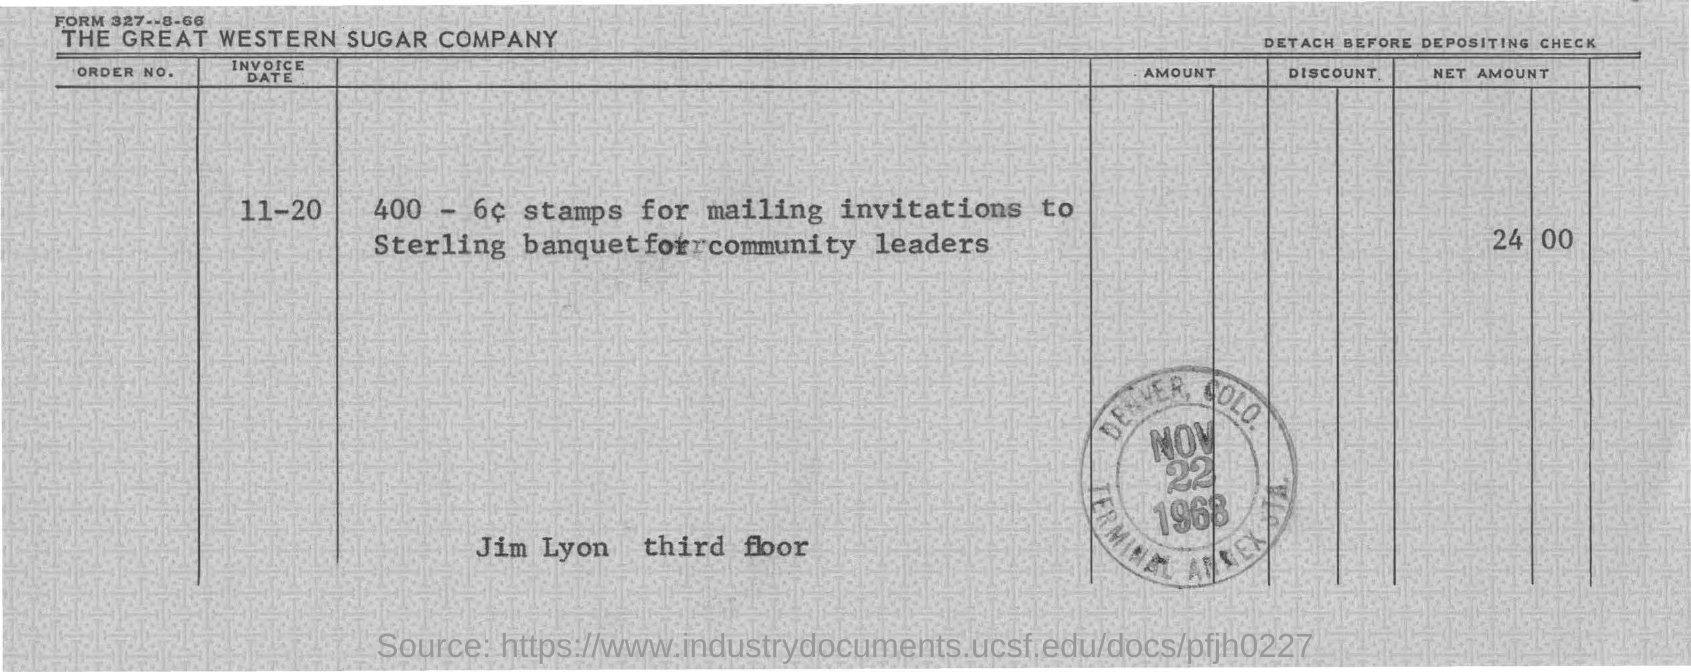Draw attention to some important aspects in this diagram. The invoice date is November 20. The net amount is 24,000. 